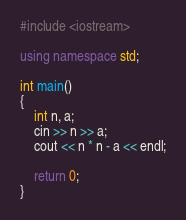Convert code to text. <code><loc_0><loc_0><loc_500><loc_500><_C++_>#include <iostream>

using namespace std;

int main()
{
	int n, a;
	cin >> n >> a;
	cout << n * n - a << endl;

	return 0;
}</code> 